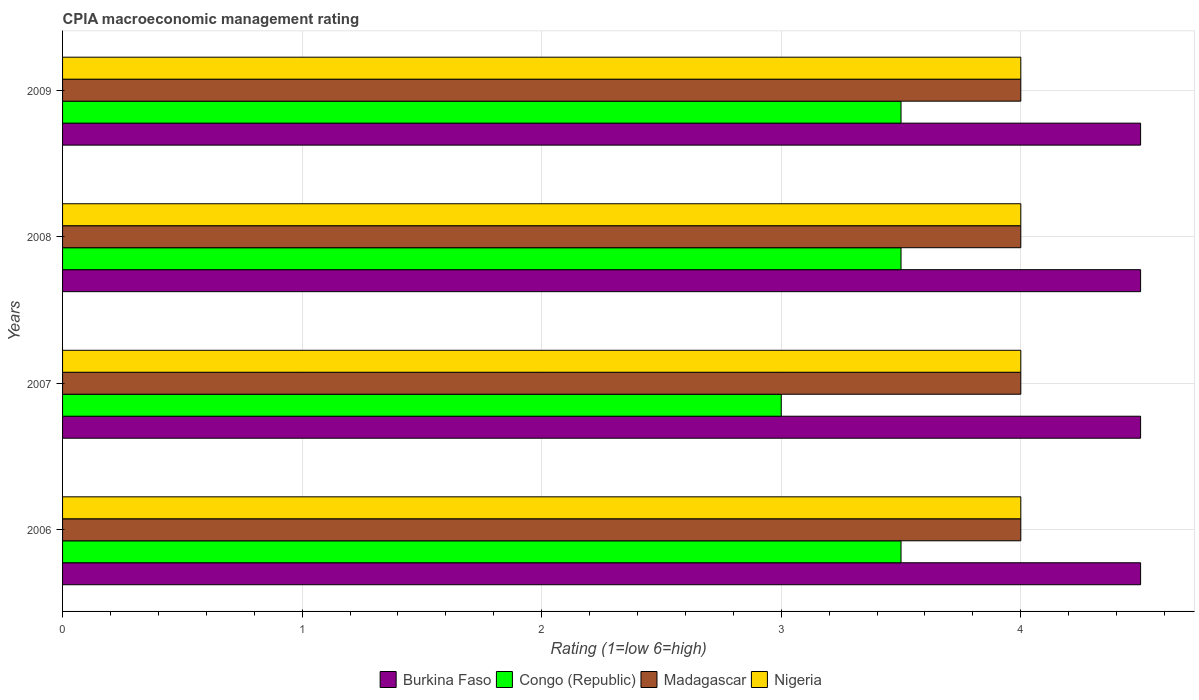How many different coloured bars are there?
Offer a very short reply. 4. How many groups of bars are there?
Provide a succinct answer. 4. In how many cases, is the number of bars for a given year not equal to the number of legend labels?
Provide a succinct answer. 0. What is the CPIA rating in Nigeria in 2007?
Keep it short and to the point. 4. Across all years, what is the maximum CPIA rating in Congo (Republic)?
Offer a terse response. 3.5. In which year was the CPIA rating in Congo (Republic) maximum?
Keep it short and to the point. 2006. In which year was the CPIA rating in Madagascar minimum?
Offer a terse response. 2006. What is the difference between the CPIA rating in Madagascar in 2008 and the CPIA rating in Nigeria in 2007?
Provide a succinct answer. 0. What is the average CPIA rating in Congo (Republic) per year?
Provide a short and direct response. 3.38. Is the difference between the CPIA rating in Burkina Faso in 2006 and 2008 greater than the difference between the CPIA rating in Congo (Republic) in 2006 and 2008?
Your answer should be very brief. No. What is the difference between the highest and the second highest CPIA rating in Madagascar?
Offer a terse response. 0. What is the difference between the highest and the lowest CPIA rating in Madagascar?
Offer a terse response. 0. In how many years, is the CPIA rating in Congo (Republic) greater than the average CPIA rating in Congo (Republic) taken over all years?
Make the answer very short. 3. Is it the case that in every year, the sum of the CPIA rating in Nigeria and CPIA rating in Congo (Republic) is greater than the sum of CPIA rating in Burkina Faso and CPIA rating in Madagascar?
Ensure brevity in your answer.  No. What does the 3rd bar from the top in 2008 represents?
Your response must be concise. Congo (Republic). What does the 2nd bar from the bottom in 2006 represents?
Offer a very short reply. Congo (Republic). How many bars are there?
Offer a terse response. 16. Are all the bars in the graph horizontal?
Your answer should be very brief. Yes. What is the difference between two consecutive major ticks on the X-axis?
Your response must be concise. 1. Are the values on the major ticks of X-axis written in scientific E-notation?
Provide a short and direct response. No. Does the graph contain any zero values?
Your response must be concise. No. Where does the legend appear in the graph?
Your response must be concise. Bottom center. How many legend labels are there?
Provide a succinct answer. 4. What is the title of the graph?
Offer a terse response. CPIA macroeconomic management rating. Does "Togo" appear as one of the legend labels in the graph?
Ensure brevity in your answer.  No. What is the Rating (1=low 6=high) of Burkina Faso in 2006?
Ensure brevity in your answer.  4.5. What is the Rating (1=low 6=high) in Madagascar in 2006?
Your answer should be compact. 4. What is the Rating (1=low 6=high) of Nigeria in 2006?
Offer a very short reply. 4. What is the Rating (1=low 6=high) in Burkina Faso in 2007?
Give a very brief answer. 4.5. What is the Rating (1=low 6=high) in Congo (Republic) in 2008?
Offer a terse response. 3.5. What is the Rating (1=low 6=high) of Madagascar in 2008?
Your response must be concise. 4. What is the Rating (1=low 6=high) in Burkina Faso in 2009?
Keep it short and to the point. 4.5. What is the Rating (1=low 6=high) in Congo (Republic) in 2009?
Your answer should be very brief. 3.5. What is the Rating (1=low 6=high) of Madagascar in 2009?
Give a very brief answer. 4. Across all years, what is the maximum Rating (1=low 6=high) in Congo (Republic)?
Keep it short and to the point. 3.5. Across all years, what is the minimum Rating (1=low 6=high) in Burkina Faso?
Your answer should be very brief. 4.5. Across all years, what is the minimum Rating (1=low 6=high) in Congo (Republic)?
Ensure brevity in your answer.  3. Across all years, what is the minimum Rating (1=low 6=high) in Madagascar?
Your answer should be very brief. 4. Across all years, what is the minimum Rating (1=low 6=high) of Nigeria?
Make the answer very short. 4. What is the total Rating (1=low 6=high) in Burkina Faso in the graph?
Ensure brevity in your answer.  18. What is the difference between the Rating (1=low 6=high) in Burkina Faso in 2006 and that in 2007?
Provide a short and direct response. 0. What is the difference between the Rating (1=low 6=high) of Madagascar in 2006 and that in 2007?
Your answer should be compact. 0. What is the difference between the Rating (1=low 6=high) in Congo (Republic) in 2006 and that in 2008?
Provide a succinct answer. 0. What is the difference between the Rating (1=low 6=high) in Nigeria in 2006 and that in 2008?
Keep it short and to the point. 0. What is the difference between the Rating (1=low 6=high) in Nigeria in 2006 and that in 2009?
Offer a very short reply. 0. What is the difference between the Rating (1=low 6=high) in Burkina Faso in 2007 and that in 2008?
Your answer should be compact. 0. What is the difference between the Rating (1=low 6=high) in Madagascar in 2007 and that in 2009?
Offer a very short reply. 0. What is the difference between the Rating (1=low 6=high) in Nigeria in 2007 and that in 2009?
Give a very brief answer. 0. What is the difference between the Rating (1=low 6=high) in Burkina Faso in 2008 and that in 2009?
Provide a succinct answer. 0. What is the difference between the Rating (1=low 6=high) in Congo (Republic) in 2008 and that in 2009?
Provide a short and direct response. 0. What is the difference between the Rating (1=low 6=high) in Burkina Faso in 2006 and the Rating (1=low 6=high) in Congo (Republic) in 2007?
Your answer should be compact. 1.5. What is the difference between the Rating (1=low 6=high) in Burkina Faso in 2006 and the Rating (1=low 6=high) in Nigeria in 2007?
Make the answer very short. 0.5. What is the difference between the Rating (1=low 6=high) of Madagascar in 2006 and the Rating (1=low 6=high) of Nigeria in 2007?
Your response must be concise. 0. What is the difference between the Rating (1=low 6=high) of Burkina Faso in 2006 and the Rating (1=low 6=high) of Nigeria in 2008?
Offer a very short reply. 0.5. What is the difference between the Rating (1=low 6=high) in Madagascar in 2006 and the Rating (1=low 6=high) in Nigeria in 2008?
Give a very brief answer. 0. What is the difference between the Rating (1=low 6=high) of Burkina Faso in 2006 and the Rating (1=low 6=high) of Nigeria in 2009?
Your answer should be very brief. 0.5. What is the difference between the Rating (1=low 6=high) of Burkina Faso in 2007 and the Rating (1=low 6=high) of Congo (Republic) in 2008?
Provide a short and direct response. 1. What is the difference between the Rating (1=low 6=high) in Burkina Faso in 2007 and the Rating (1=low 6=high) in Madagascar in 2008?
Your answer should be compact. 0.5. What is the difference between the Rating (1=low 6=high) of Burkina Faso in 2007 and the Rating (1=low 6=high) of Nigeria in 2008?
Keep it short and to the point. 0.5. What is the difference between the Rating (1=low 6=high) of Burkina Faso in 2007 and the Rating (1=low 6=high) of Nigeria in 2009?
Your answer should be very brief. 0.5. What is the difference between the Rating (1=low 6=high) of Congo (Republic) in 2007 and the Rating (1=low 6=high) of Madagascar in 2009?
Your answer should be very brief. -1. What is the difference between the Rating (1=low 6=high) in Madagascar in 2007 and the Rating (1=low 6=high) in Nigeria in 2009?
Provide a succinct answer. 0. What is the difference between the Rating (1=low 6=high) in Burkina Faso in 2008 and the Rating (1=low 6=high) in Congo (Republic) in 2009?
Make the answer very short. 1. What is the average Rating (1=low 6=high) in Burkina Faso per year?
Provide a succinct answer. 4.5. What is the average Rating (1=low 6=high) of Congo (Republic) per year?
Keep it short and to the point. 3.38. What is the average Rating (1=low 6=high) of Madagascar per year?
Keep it short and to the point. 4. What is the average Rating (1=low 6=high) in Nigeria per year?
Offer a terse response. 4. In the year 2006, what is the difference between the Rating (1=low 6=high) in Burkina Faso and Rating (1=low 6=high) in Madagascar?
Ensure brevity in your answer.  0.5. In the year 2006, what is the difference between the Rating (1=low 6=high) in Congo (Republic) and Rating (1=low 6=high) in Madagascar?
Provide a short and direct response. -0.5. In the year 2006, what is the difference between the Rating (1=low 6=high) of Congo (Republic) and Rating (1=low 6=high) of Nigeria?
Offer a terse response. -0.5. In the year 2006, what is the difference between the Rating (1=low 6=high) in Madagascar and Rating (1=low 6=high) in Nigeria?
Give a very brief answer. 0. In the year 2007, what is the difference between the Rating (1=low 6=high) of Burkina Faso and Rating (1=low 6=high) of Madagascar?
Your answer should be compact. 0.5. In the year 2007, what is the difference between the Rating (1=low 6=high) in Congo (Republic) and Rating (1=low 6=high) in Madagascar?
Provide a succinct answer. -1. In the year 2007, what is the difference between the Rating (1=low 6=high) in Madagascar and Rating (1=low 6=high) in Nigeria?
Offer a very short reply. 0. In the year 2008, what is the difference between the Rating (1=low 6=high) of Burkina Faso and Rating (1=low 6=high) of Nigeria?
Ensure brevity in your answer.  0.5. In the year 2008, what is the difference between the Rating (1=low 6=high) in Congo (Republic) and Rating (1=low 6=high) in Madagascar?
Keep it short and to the point. -0.5. In the year 2008, what is the difference between the Rating (1=low 6=high) of Congo (Republic) and Rating (1=low 6=high) of Nigeria?
Your response must be concise. -0.5. In the year 2009, what is the difference between the Rating (1=low 6=high) in Burkina Faso and Rating (1=low 6=high) in Congo (Republic)?
Provide a short and direct response. 1. In the year 2009, what is the difference between the Rating (1=low 6=high) of Burkina Faso and Rating (1=low 6=high) of Madagascar?
Ensure brevity in your answer.  0.5. In the year 2009, what is the difference between the Rating (1=low 6=high) of Congo (Republic) and Rating (1=low 6=high) of Madagascar?
Ensure brevity in your answer.  -0.5. In the year 2009, what is the difference between the Rating (1=low 6=high) in Congo (Republic) and Rating (1=low 6=high) in Nigeria?
Provide a short and direct response. -0.5. In the year 2009, what is the difference between the Rating (1=low 6=high) of Madagascar and Rating (1=low 6=high) of Nigeria?
Provide a succinct answer. 0. What is the ratio of the Rating (1=low 6=high) in Congo (Republic) in 2006 to that in 2007?
Ensure brevity in your answer.  1.17. What is the ratio of the Rating (1=low 6=high) in Madagascar in 2006 to that in 2007?
Your response must be concise. 1. What is the ratio of the Rating (1=low 6=high) in Nigeria in 2006 to that in 2007?
Your answer should be compact. 1. What is the ratio of the Rating (1=low 6=high) in Madagascar in 2006 to that in 2008?
Offer a very short reply. 1. What is the ratio of the Rating (1=low 6=high) of Burkina Faso in 2006 to that in 2009?
Offer a terse response. 1. What is the ratio of the Rating (1=low 6=high) of Congo (Republic) in 2006 to that in 2009?
Offer a terse response. 1. What is the ratio of the Rating (1=low 6=high) in Madagascar in 2007 to that in 2008?
Your answer should be compact. 1. What is the ratio of the Rating (1=low 6=high) in Nigeria in 2007 to that in 2008?
Provide a succinct answer. 1. What is the ratio of the Rating (1=low 6=high) of Burkina Faso in 2007 to that in 2009?
Offer a very short reply. 1. What is the ratio of the Rating (1=low 6=high) of Congo (Republic) in 2007 to that in 2009?
Your answer should be compact. 0.86. What is the ratio of the Rating (1=low 6=high) of Madagascar in 2007 to that in 2009?
Your answer should be compact. 1. What is the ratio of the Rating (1=low 6=high) of Nigeria in 2007 to that in 2009?
Provide a short and direct response. 1. What is the ratio of the Rating (1=low 6=high) of Burkina Faso in 2008 to that in 2009?
Make the answer very short. 1. What is the ratio of the Rating (1=low 6=high) of Congo (Republic) in 2008 to that in 2009?
Make the answer very short. 1. What is the ratio of the Rating (1=low 6=high) in Nigeria in 2008 to that in 2009?
Your response must be concise. 1. What is the difference between the highest and the second highest Rating (1=low 6=high) of Burkina Faso?
Your response must be concise. 0. What is the difference between the highest and the second highest Rating (1=low 6=high) in Congo (Republic)?
Ensure brevity in your answer.  0. What is the difference between the highest and the lowest Rating (1=low 6=high) of Nigeria?
Provide a short and direct response. 0. 